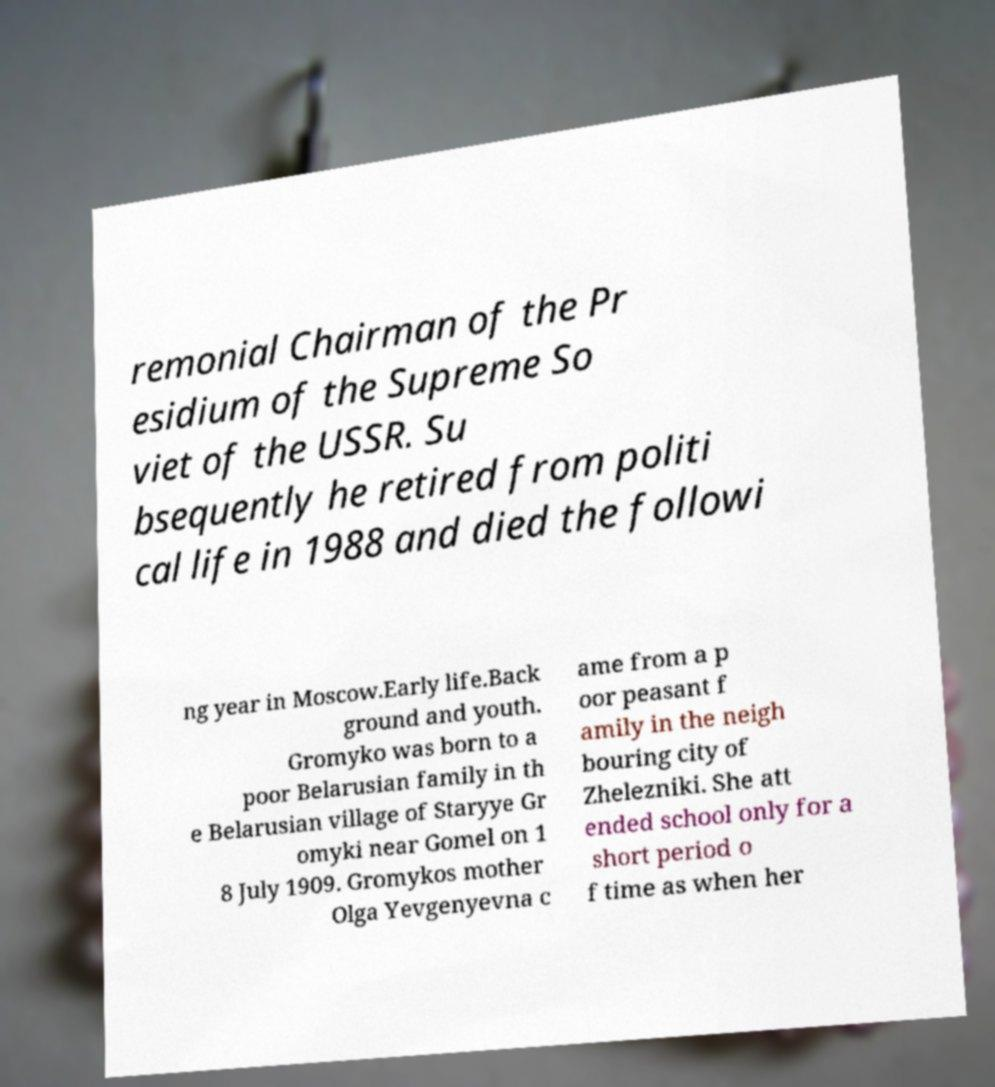Please read and relay the text visible in this image. What does it say? remonial Chairman of the Pr esidium of the Supreme So viet of the USSR. Su bsequently he retired from politi cal life in 1988 and died the followi ng year in Moscow.Early life.Back ground and youth. Gromyko was born to a poor Belarusian family in th e Belarusian village of Staryye Gr omyki near Gomel on 1 8 July 1909. Gromykos mother Olga Yevgenyevna c ame from a p oor peasant f amily in the neigh bouring city of Zhelezniki. She att ended school only for a short period o f time as when her 